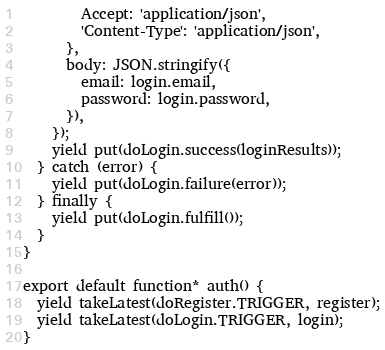<code> <loc_0><loc_0><loc_500><loc_500><_JavaScript_>        Accept: 'application/json',
        'Content-Type': 'application/json',
      },
      body: JSON.stringify({
        email: login.email,
        password: login.password,
      }),
    });
    yield put(doLogin.success(loginResults));
  } catch (error) {
    yield put(doLogin.failure(error));
  } finally {
    yield put(doLogin.fulfill());
  }
}

export default function* auth() {
  yield takeLatest(doRegister.TRIGGER, register);
  yield takeLatest(doLogin.TRIGGER, login);
}
</code> 